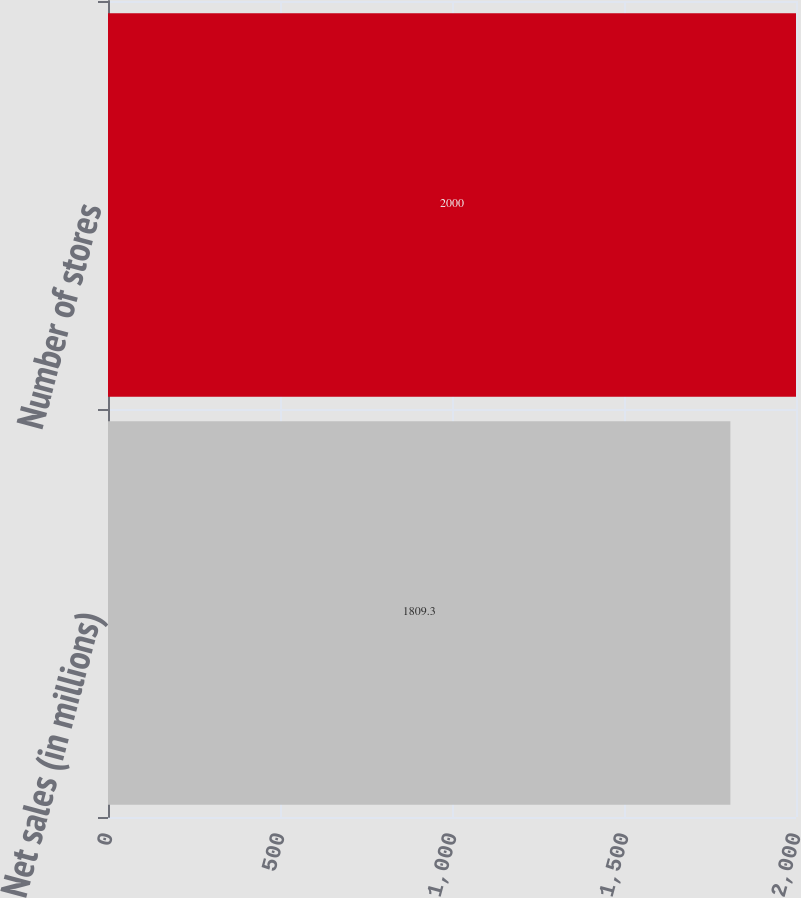Convert chart. <chart><loc_0><loc_0><loc_500><loc_500><bar_chart><fcel>Net sales (in millions)<fcel>Number of stores<nl><fcel>1809.3<fcel>2000<nl></chart> 